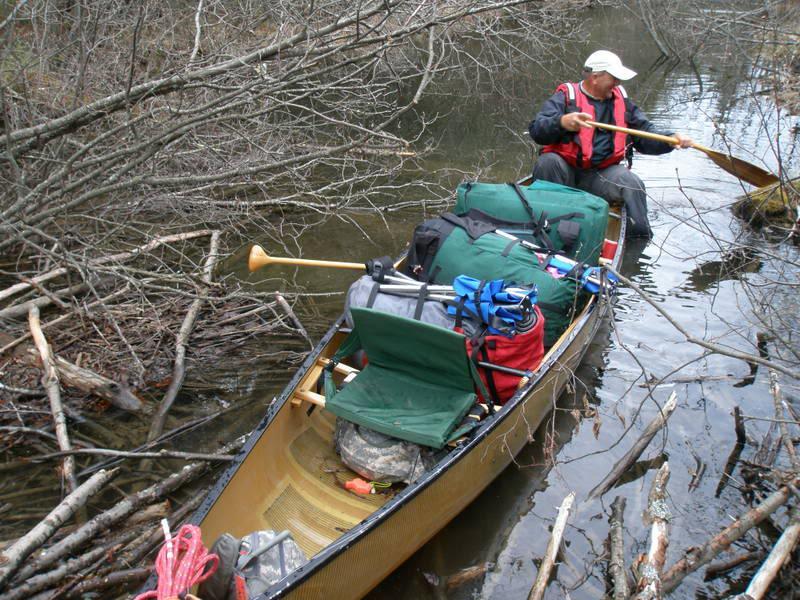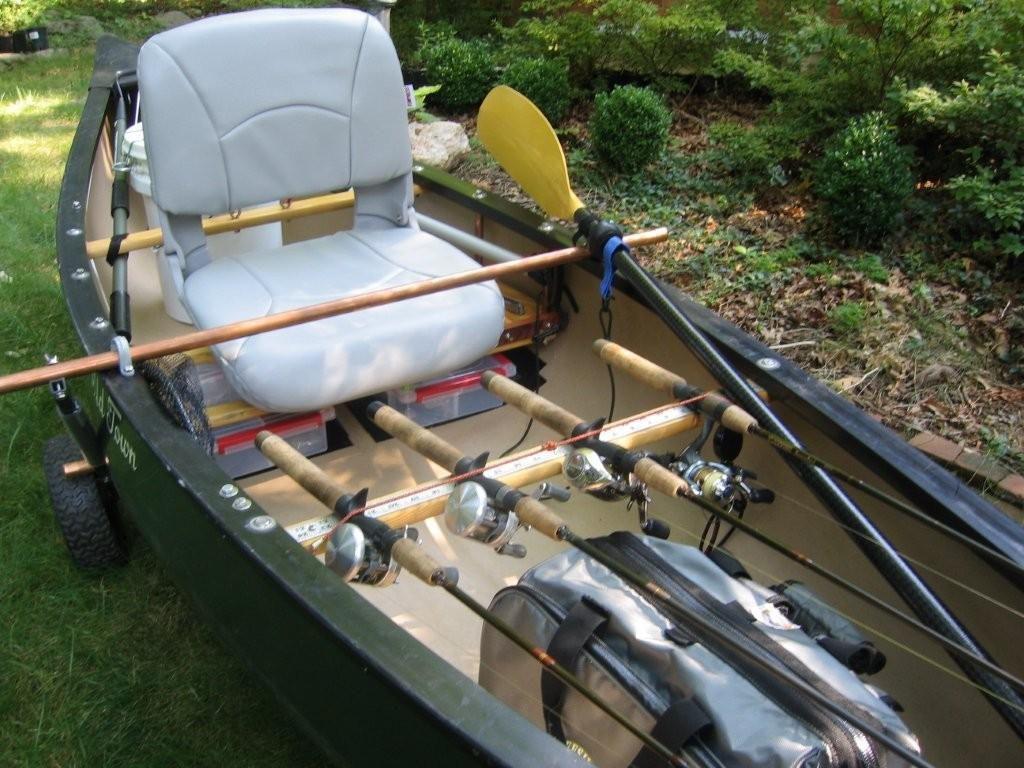The first image is the image on the left, the second image is the image on the right. Given the left and right images, does the statement "At least one of the boats is not near water." hold true? Answer yes or no. Yes. The first image is the image on the left, the second image is the image on the right. Evaluate the accuracy of this statement regarding the images: "At least one boat is not touching water.". Is it true? Answer yes or no. Yes. 